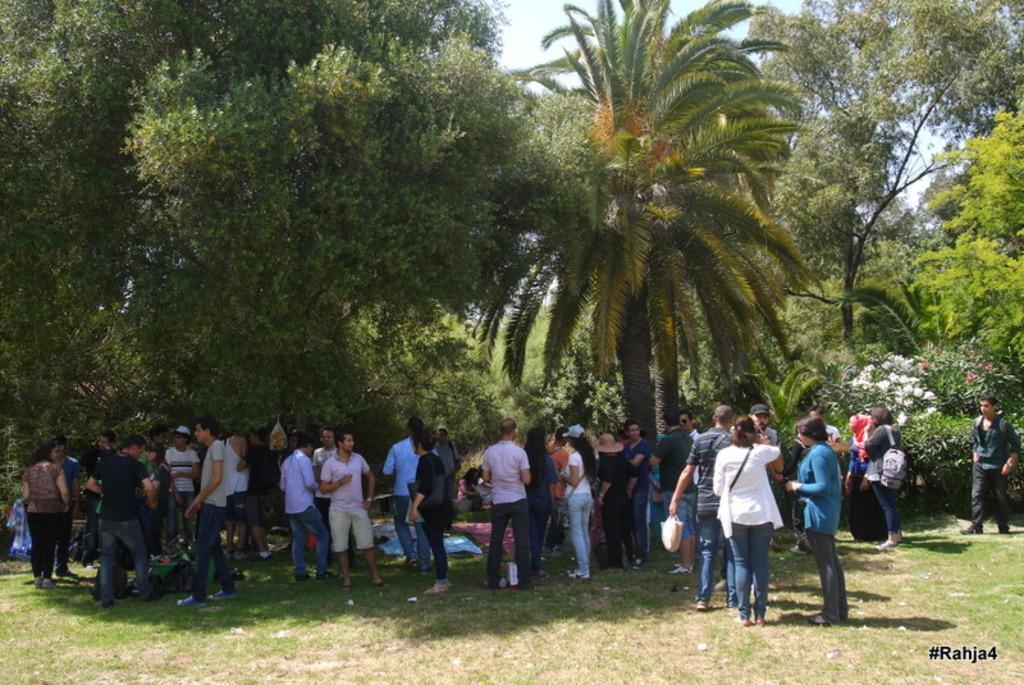In one or two sentences, can you explain what this image depicts? In this image we can see the people standing on the grass. In the background we can see many trees and also flower plants. In the bottom right corner there is text. Sky is also visible. 